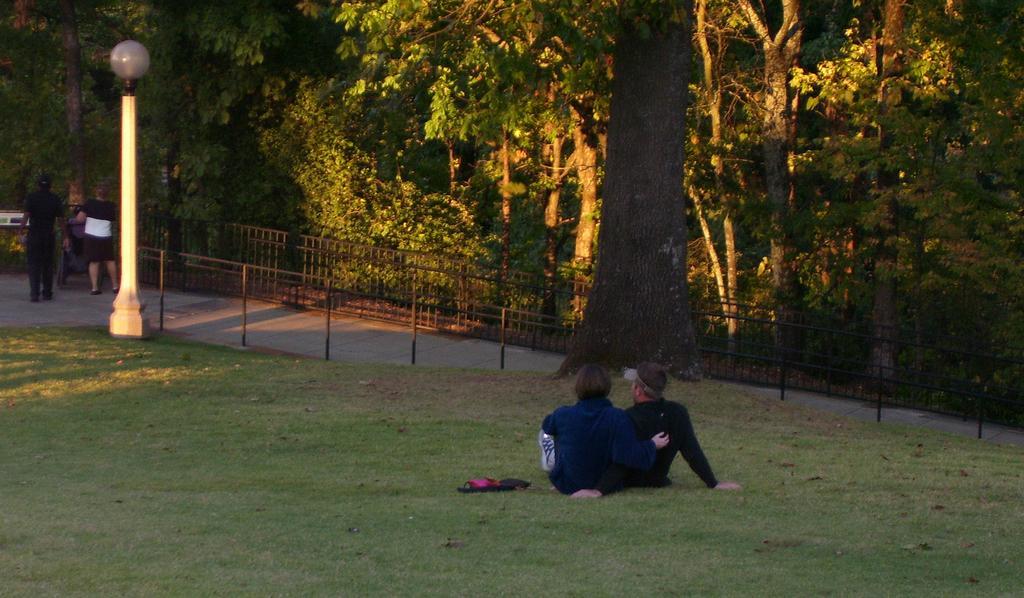Please provide a concise description of this image. In this picture we can see a group of people on the ground, some people are standing, some people are sitting, here we can see flip flops, pole with a light and fence and in the background we can see trees. 